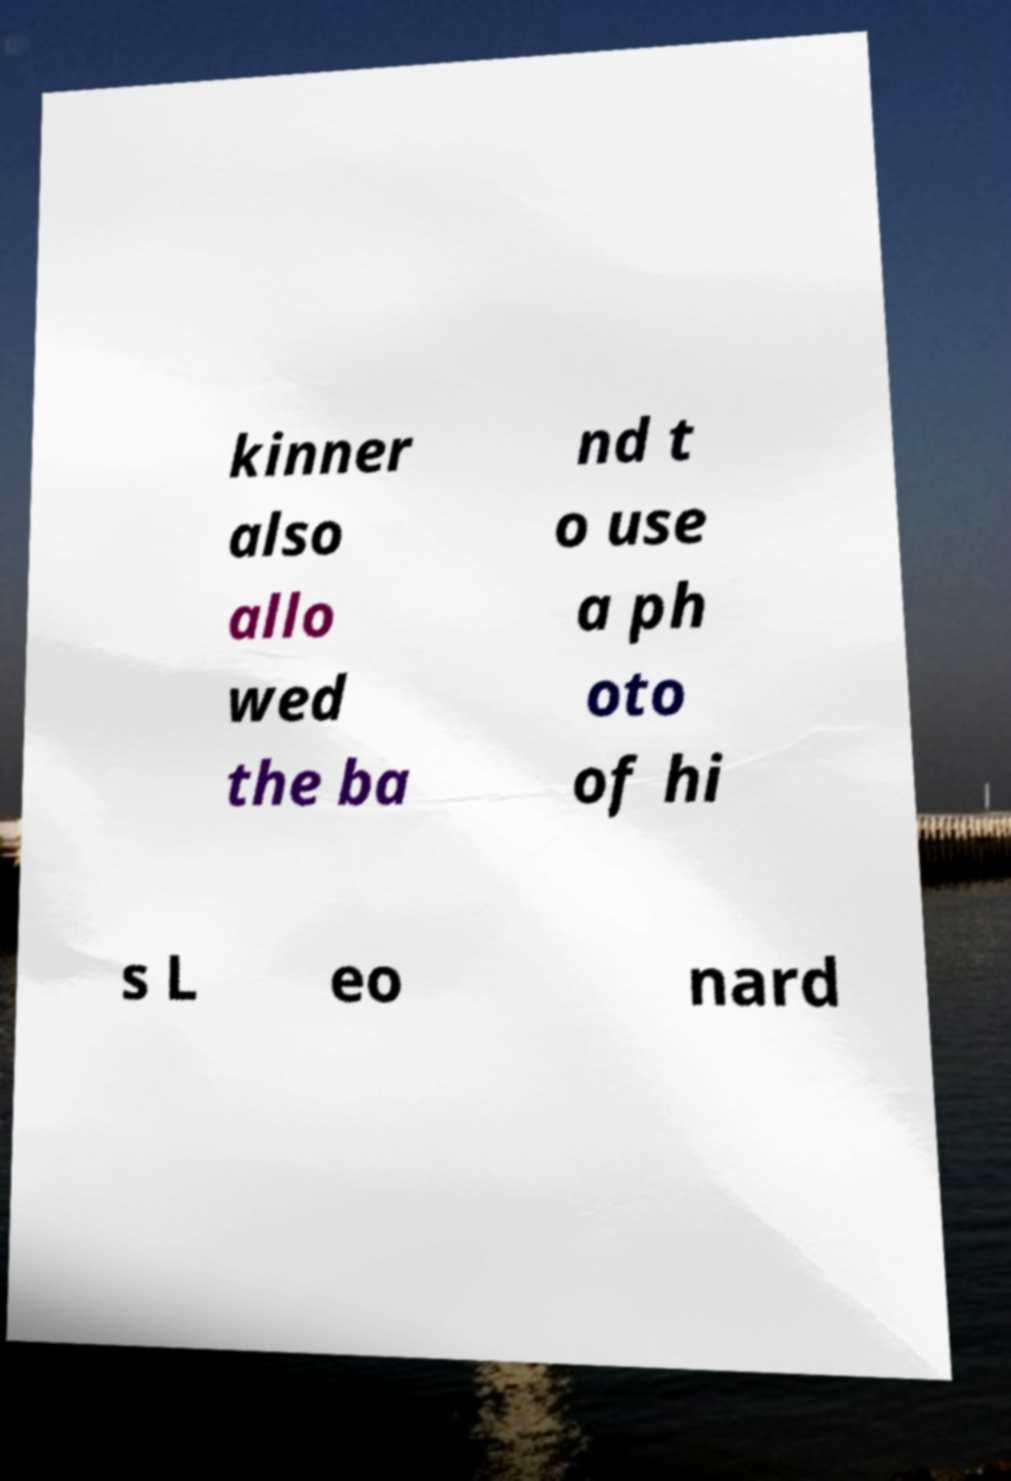Could you assist in decoding the text presented in this image and type it out clearly? kinner also allo wed the ba nd t o use a ph oto of hi s L eo nard 